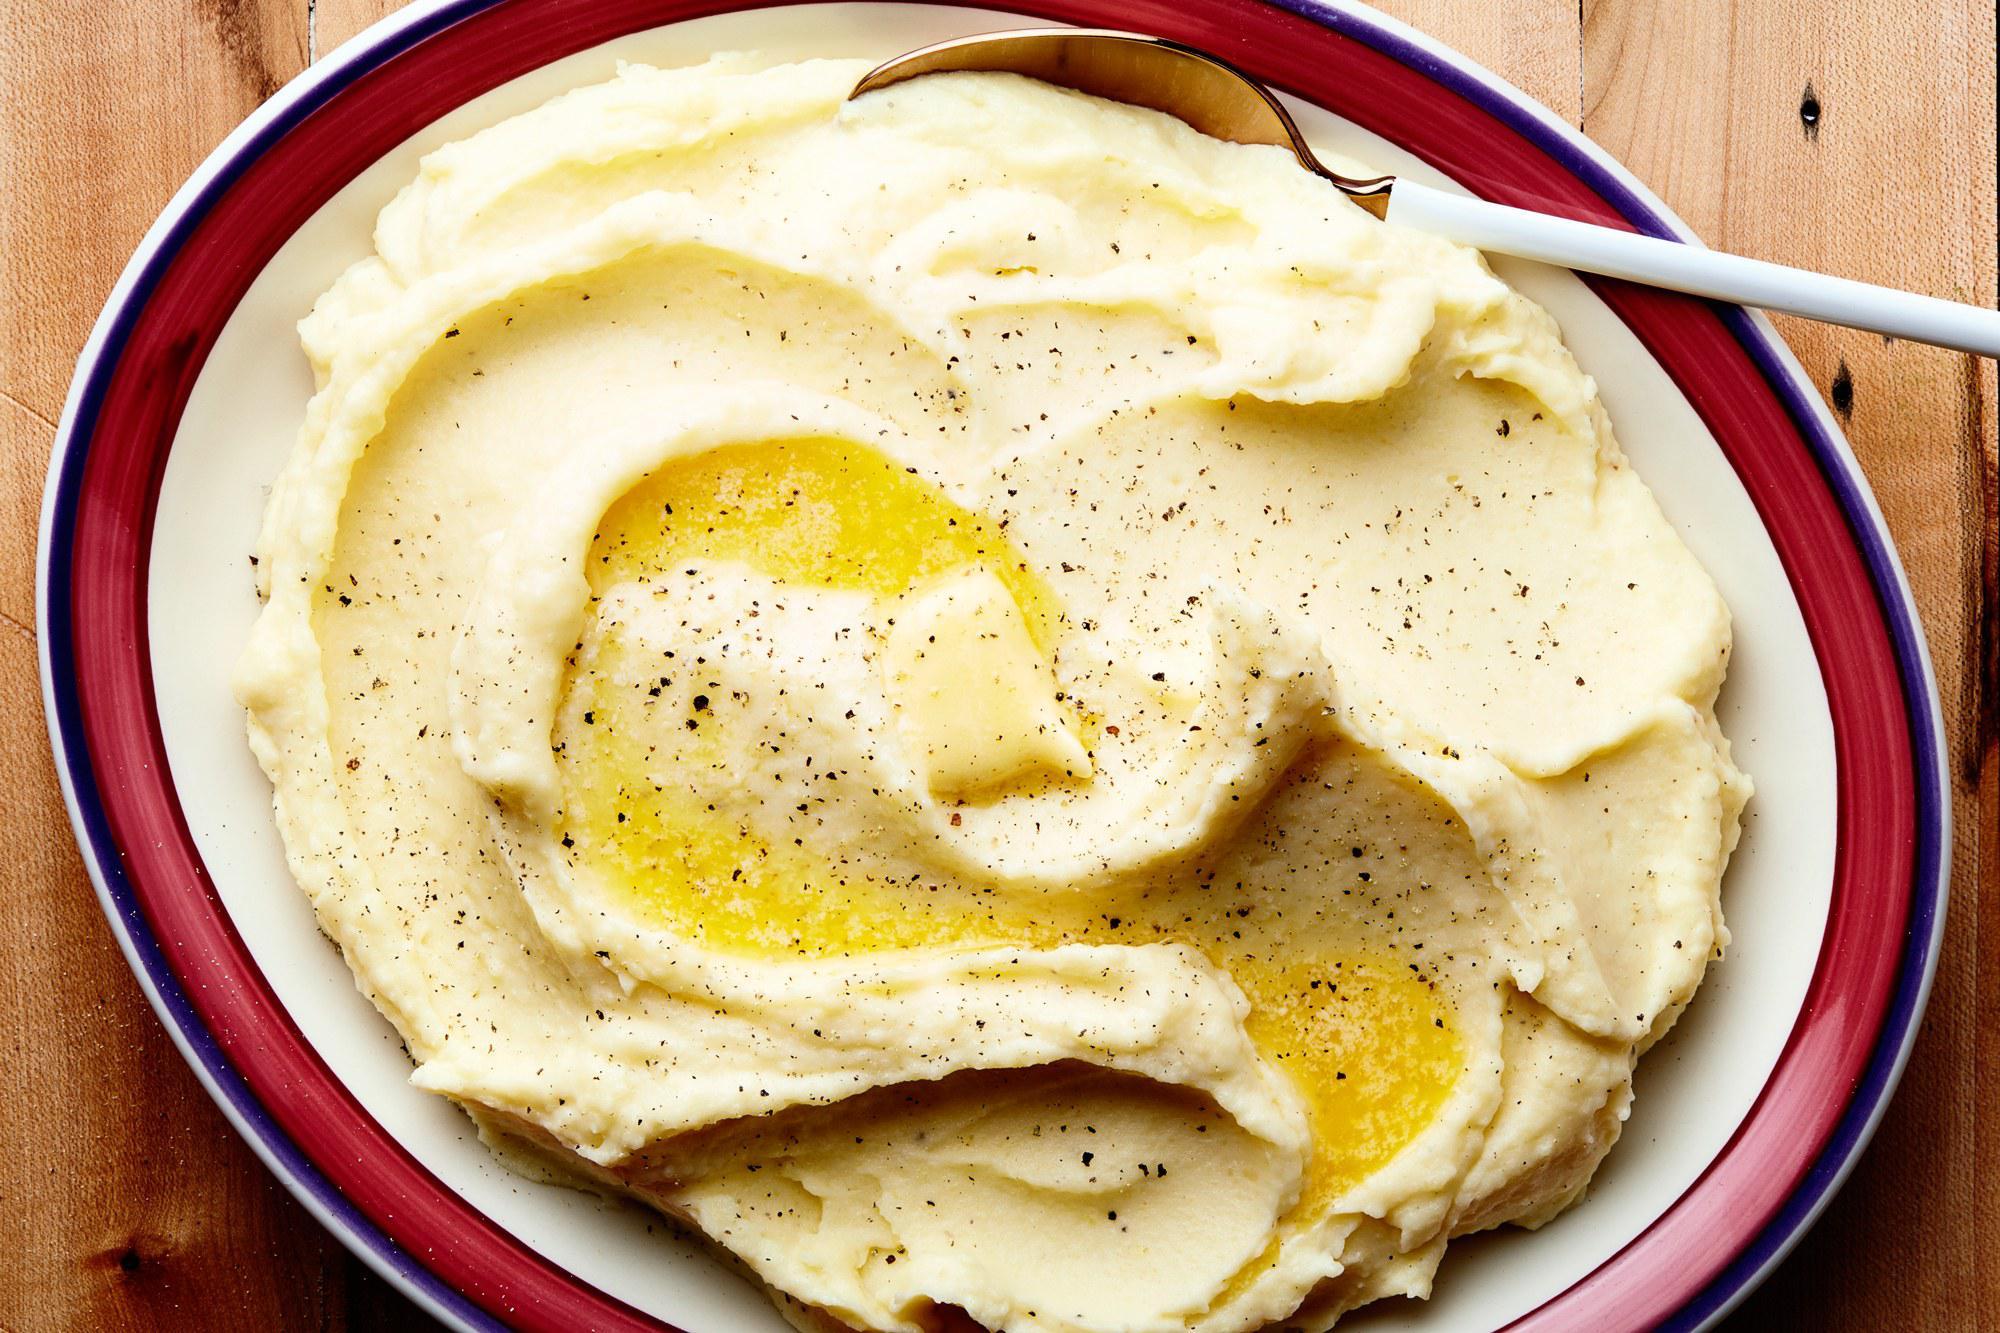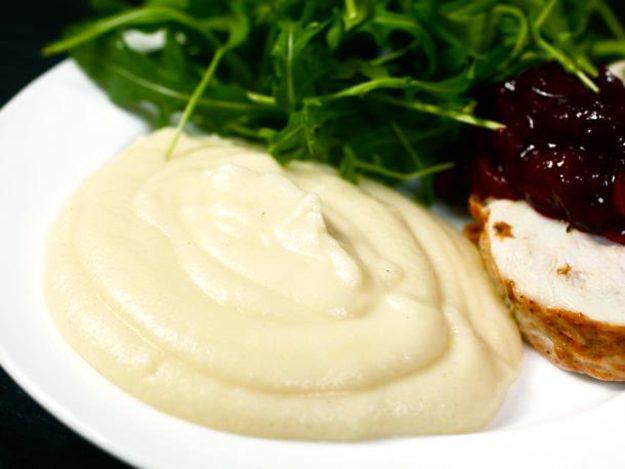The first image is the image on the left, the second image is the image on the right. Evaluate the accuracy of this statement regarding the images: "A spoon sits in a bowl of potatoes in one of the images.". Is it true? Answer yes or no. Yes. The first image is the image on the left, the second image is the image on the right. Analyze the images presented: Is the assertion "One image features a bowl of potatoes with a spoon in the food." valid? Answer yes or no. Yes. The first image is the image on the left, the second image is the image on the right. For the images displayed, is the sentence "An image shows a bowl of potatoes with handle of a utensil sticking out." factually correct? Answer yes or no. Yes. The first image is the image on the left, the second image is the image on the right. Given the left and right images, does the statement "A vegetable is visible in one of the images." hold true? Answer yes or no. Yes. 